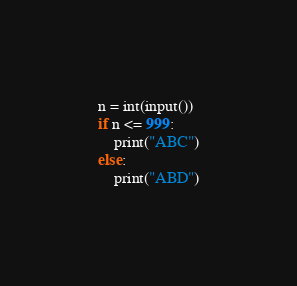<code> <loc_0><loc_0><loc_500><loc_500><_Python_>n = int(input())
if n <= 999:
    print("ABC")
else:
    print("ABD")</code> 